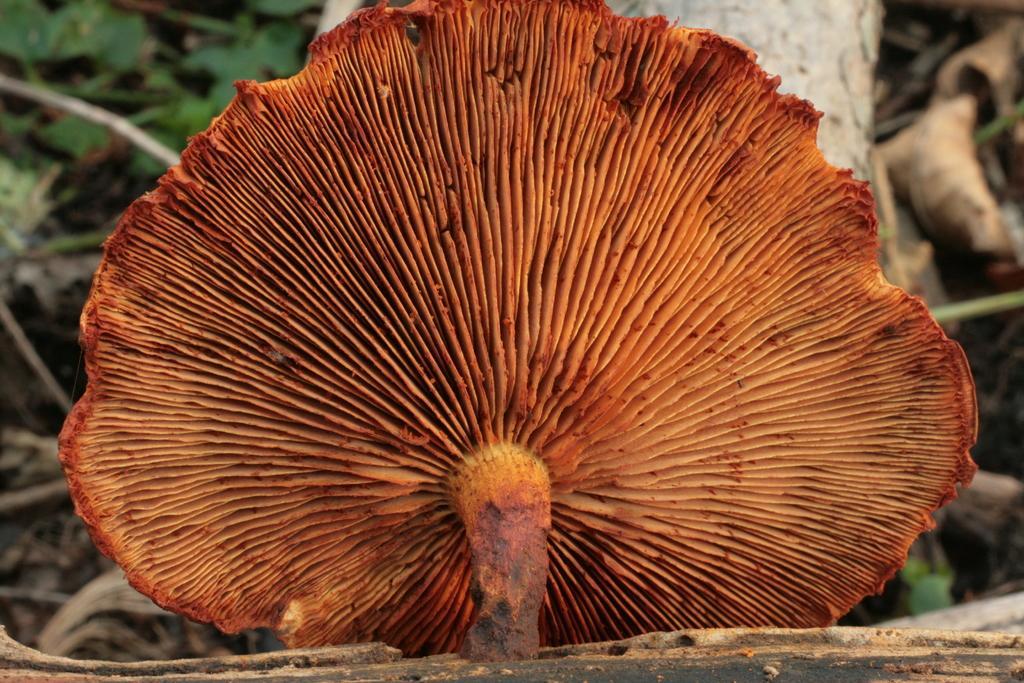Please provide a concise description of this image. This is a kind of mushroom, which is brownish in color. This looks like a wood. In the background, I think these are the leaves. 